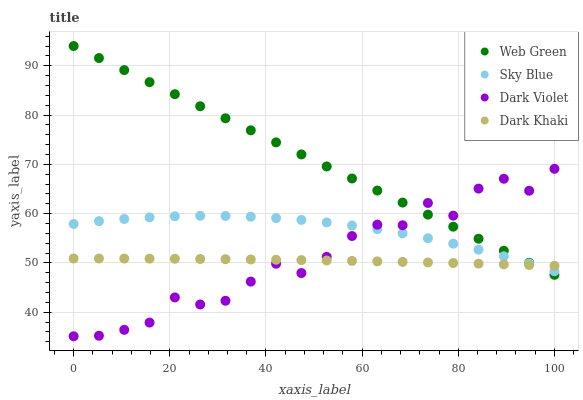Does Dark Khaki have the minimum area under the curve?
Answer yes or no. Yes. Does Web Green have the maximum area under the curve?
Answer yes or no. Yes. Does Sky Blue have the minimum area under the curve?
Answer yes or no. No. Does Sky Blue have the maximum area under the curve?
Answer yes or no. No. Is Web Green the smoothest?
Answer yes or no. Yes. Is Dark Violet the roughest?
Answer yes or no. Yes. Is Sky Blue the smoothest?
Answer yes or no. No. Is Sky Blue the roughest?
Answer yes or no. No. Does Dark Violet have the lowest value?
Answer yes or no. Yes. Does Sky Blue have the lowest value?
Answer yes or no. No. Does Web Green have the highest value?
Answer yes or no. Yes. Does Sky Blue have the highest value?
Answer yes or no. No. Does Dark Khaki intersect Web Green?
Answer yes or no. Yes. Is Dark Khaki less than Web Green?
Answer yes or no. No. Is Dark Khaki greater than Web Green?
Answer yes or no. No. 